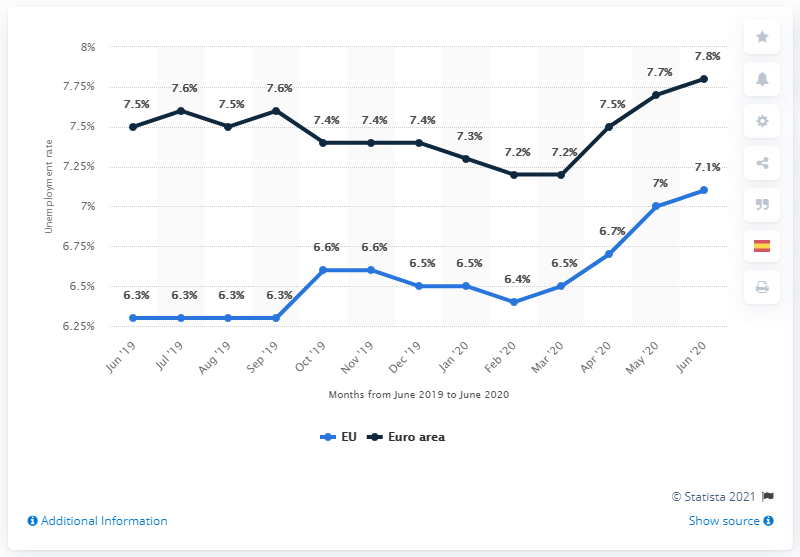Highlight a few significant elements in this photo. The unemployment rate in the European Union in June 2020 was 7.1%. The blue line increased by 0.7 units from February 2020 to June 2020. The highest value in the blue line chart is 7.1. 